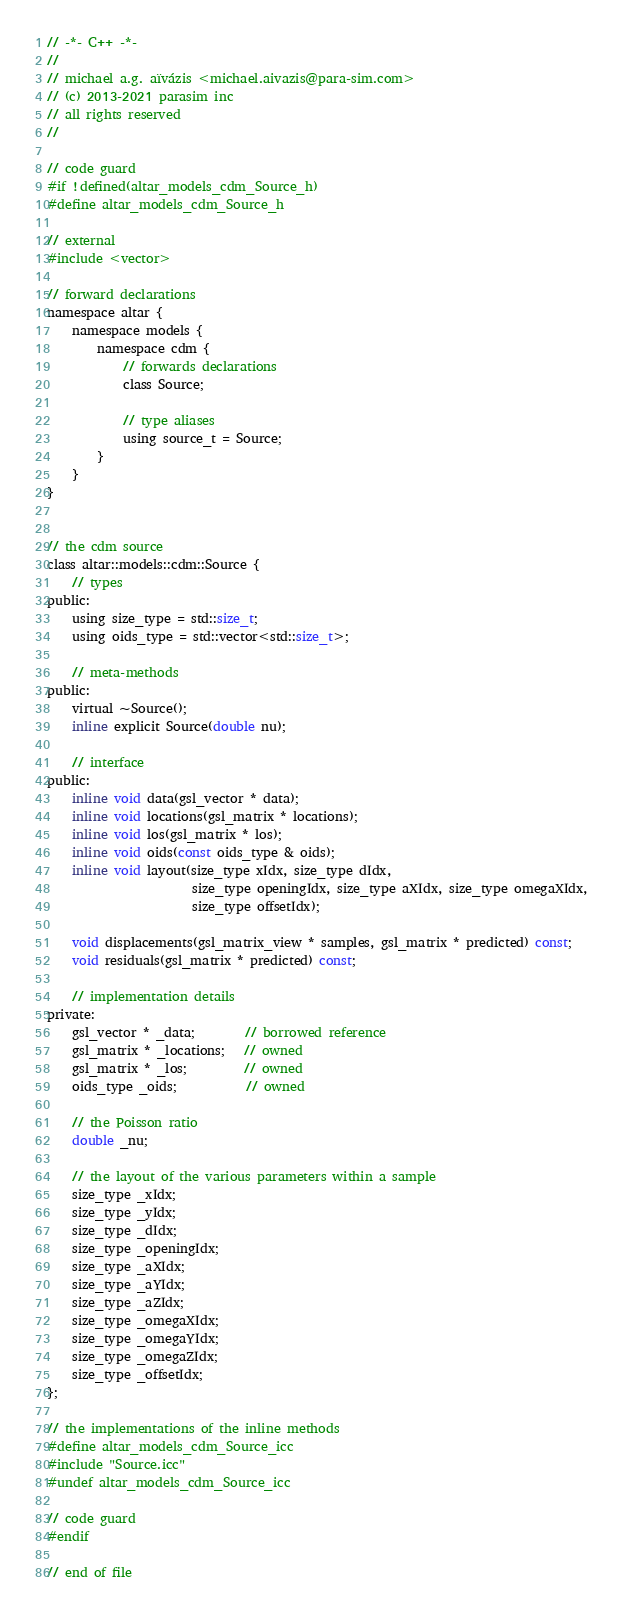Convert code to text. <code><loc_0><loc_0><loc_500><loc_500><_C_>// -*- C++ -*-
//
// michael a.g. aïvázis <michael.aivazis@para-sim.com>
// (c) 2013-2021 parasim inc
// all rights reserved
//

// code guard
#if !defined(altar_models_cdm_Source_h)
#define altar_models_cdm_Source_h

// external
#include <vector>

// forward declarations
namespace altar {
    namespace models {
        namespace cdm {
            // forwards declarations
            class Source;

            // type aliases
            using source_t = Source;
        }
    }
}


// the cdm source
class altar::models::cdm::Source {
    // types
public:
    using size_type = std::size_t;
    using oids_type = std::vector<std::size_t>;

    // meta-methods
public:
    virtual ~Source();
    inline explicit Source(double nu);

    // interface
public:
    inline void data(gsl_vector * data);
    inline void locations(gsl_matrix * locations);
    inline void los(gsl_matrix * los);
    inline void oids(const oids_type & oids);
    inline void layout(size_type xIdx, size_type dIdx,
                       size_type openingIdx, size_type aXIdx, size_type omegaXIdx,
                       size_type offsetIdx);

    void displacements(gsl_matrix_view * samples, gsl_matrix * predicted) const;
    void residuals(gsl_matrix * predicted) const;

    // implementation details
private:
    gsl_vector * _data;        // borrowed reference
    gsl_matrix * _locations;   // owned
    gsl_matrix * _los;         // owned
    oids_type _oids;           // owned

    // the Poisson ratio
    double _nu;

    // the layout of the various parameters within a sample
    size_type _xIdx;
    size_type _yIdx;
    size_type _dIdx;
    size_type _openingIdx;
    size_type _aXIdx;
    size_type _aYIdx;
    size_type _aZIdx;
    size_type _omegaXIdx;
    size_type _omegaYIdx;
    size_type _omegaZIdx;
    size_type _offsetIdx;
};

// the implementations of the inline methods
#define altar_models_cdm_Source_icc
#include "Source.icc"
#undef altar_models_cdm_Source_icc

// code guard
#endif

// end of file
</code> 